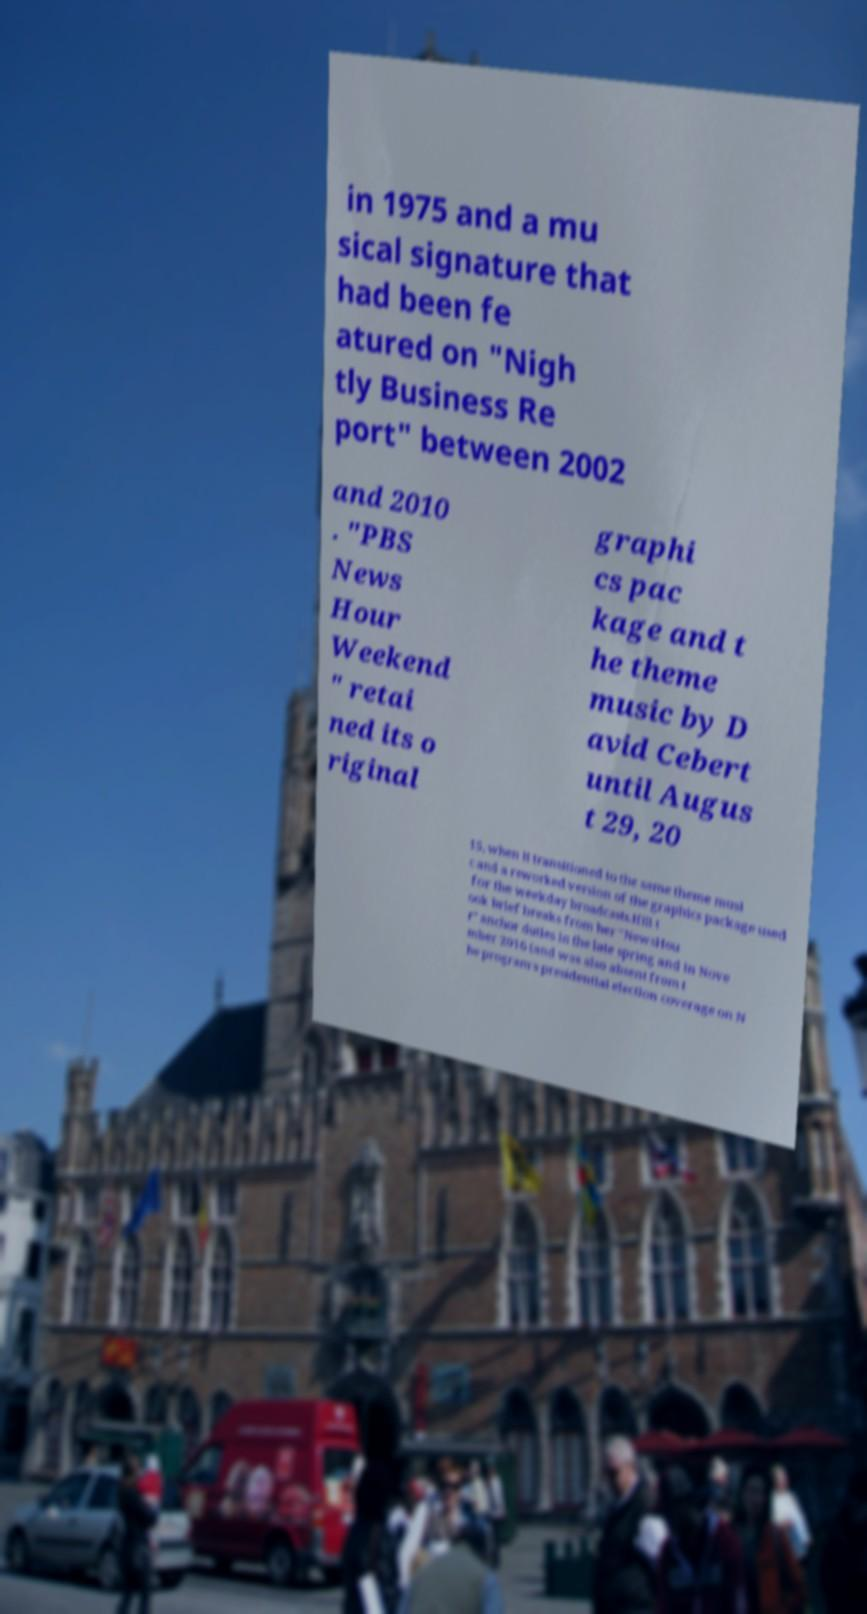What messages or text are displayed in this image? I need them in a readable, typed format. in 1975 and a mu sical signature that had been fe atured on "Nigh tly Business Re port" between 2002 and 2010 . "PBS News Hour Weekend " retai ned its o riginal graphi cs pac kage and t he theme music by D avid Cebert until Augus t 29, 20 15, when it transitioned to the same theme musi c and a reworked version of the graphics package used for the weekday broadcasts.Ifill t ook brief breaks from her "NewsHou r" anchor duties in the late spring and in Nove mber 2016 (and was also absent from t he program's presidential election coverage on N 